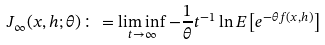Convert formula to latex. <formula><loc_0><loc_0><loc_500><loc_500>J _ { \infty } ( x , h ; \theta ) \colon = \liminf _ { t \to \infty } - \frac { 1 } { \theta } t ^ { - 1 } \ln E \left [ e ^ { - \theta f ( x , h ) } \right ]</formula> 